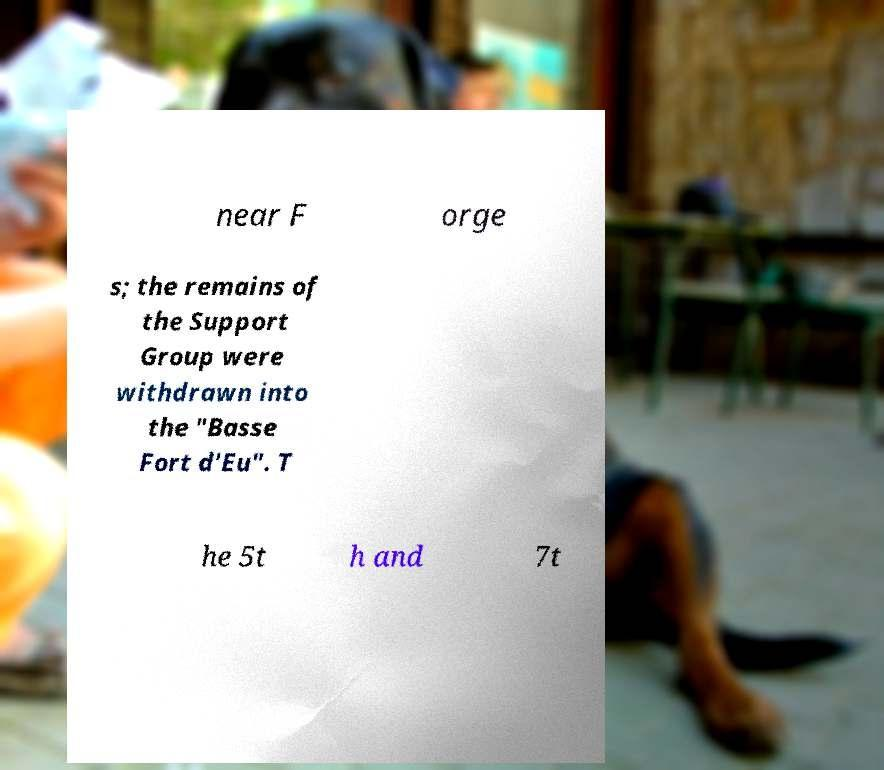For documentation purposes, I need the text within this image transcribed. Could you provide that? near F orge s; the remains of the Support Group were withdrawn into the "Basse Fort d'Eu". T he 5t h and 7t 